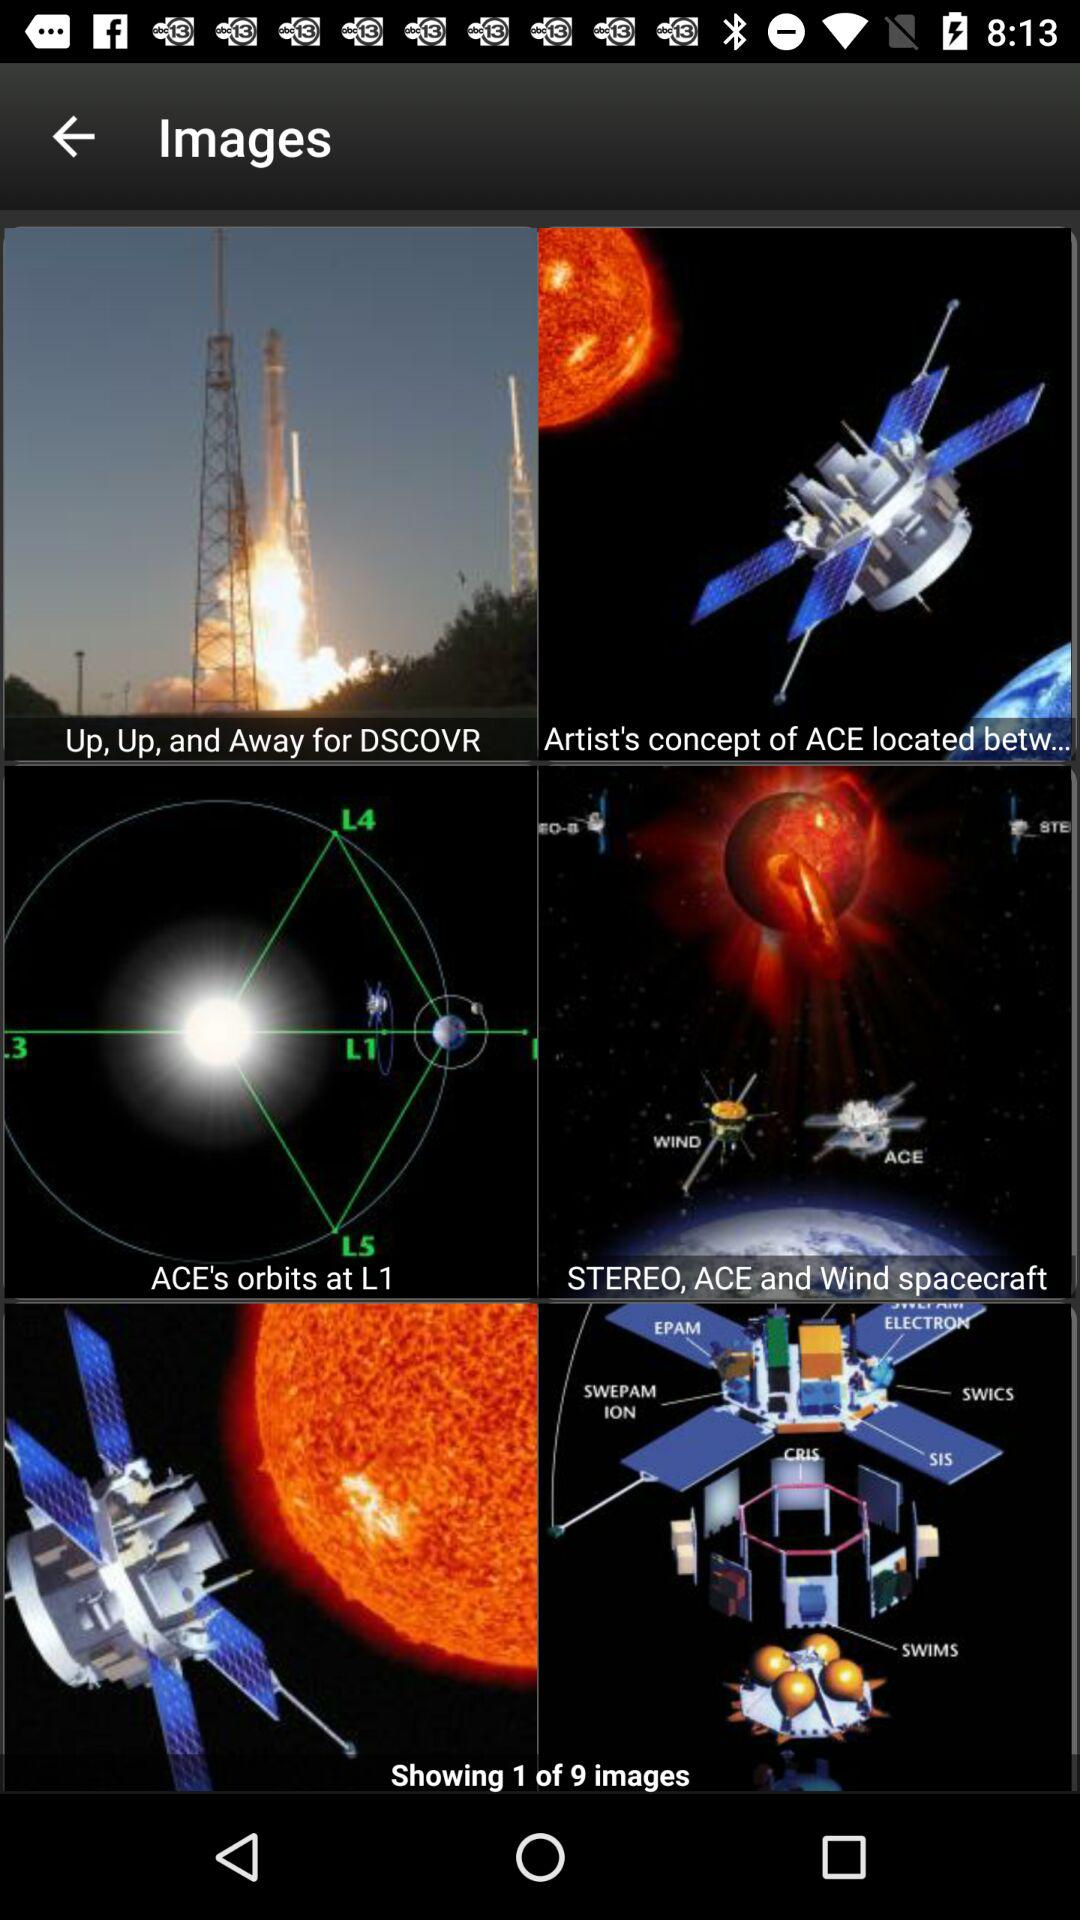Which is the current shown image number? The current shown image number is 1. 